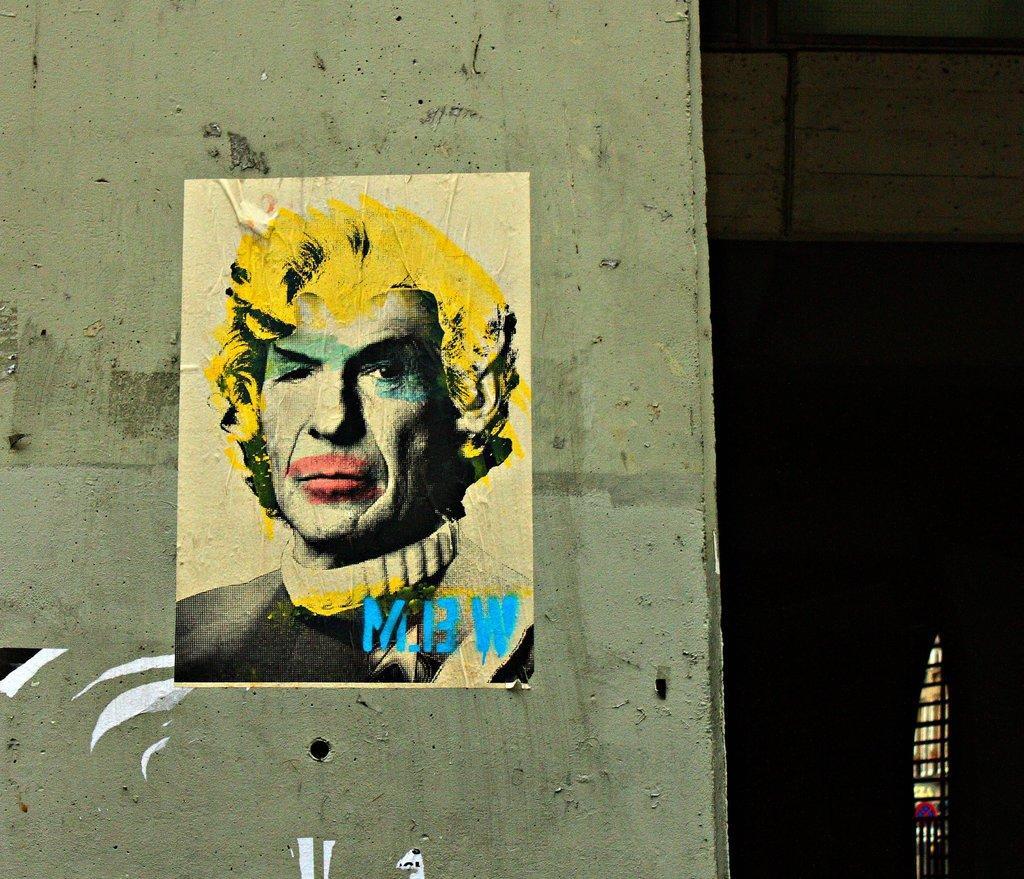Describe this image in one or two sentences. In this picture I can see there is a pillar and there is a picture posted on the pillar and there is a picture of a man with a blue water mark and the man is wearing a black shirt and on to right side there is a window. 